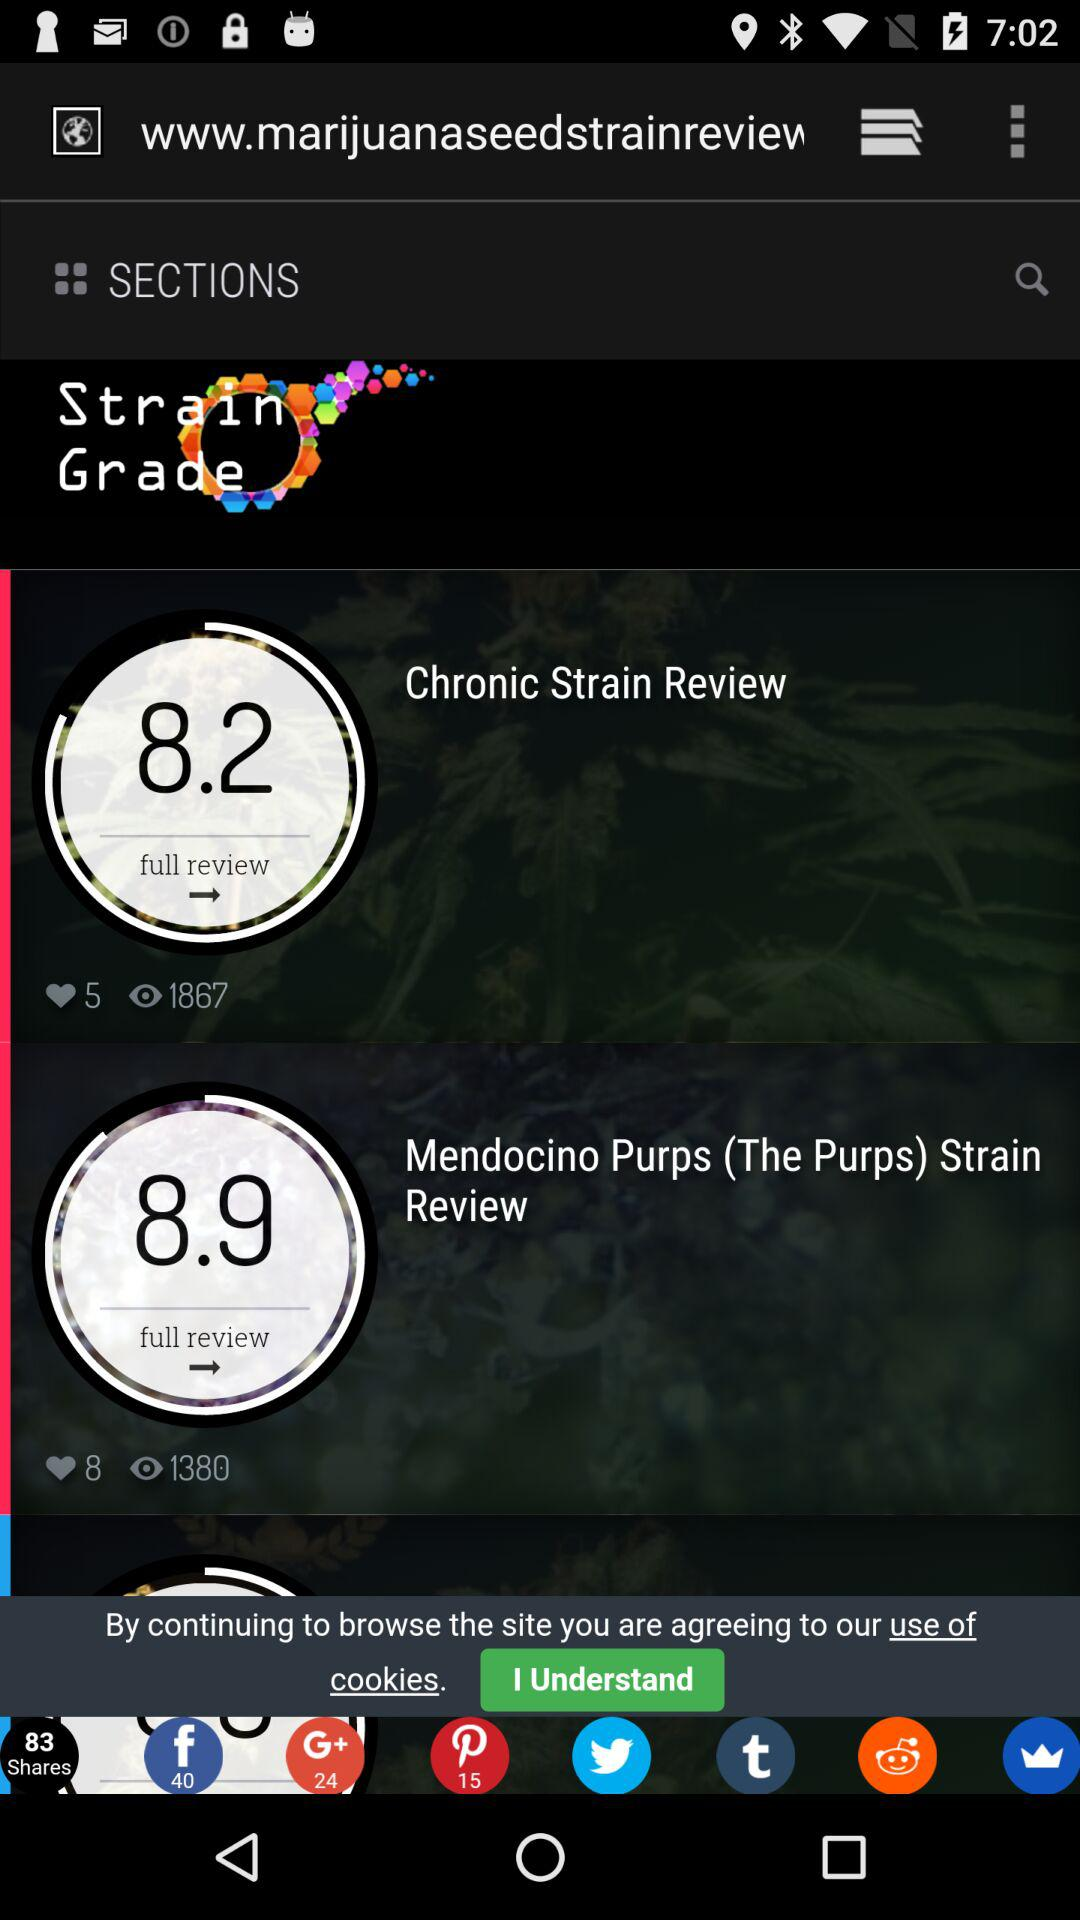How many likes are on "Mendocino Purps (The Purps) Strain Review"? There are 8 likes. 